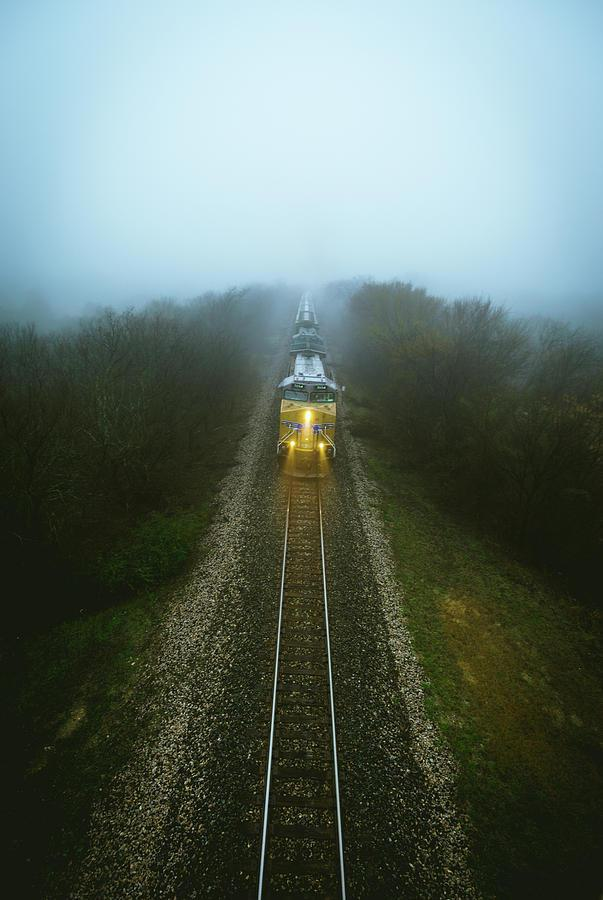Can you describe the weather conditions shown in the image? The image displays a misty or foggy weather condition, with limited visibility around the train, which is a common characteristic for early morning weather in many regions. Does the weather affect train operations? Fog can affect visibility for the train operator and may result in slower speeds or signal adjustments for safety, but trains typically have systems in place to operate in various weather conditions. 